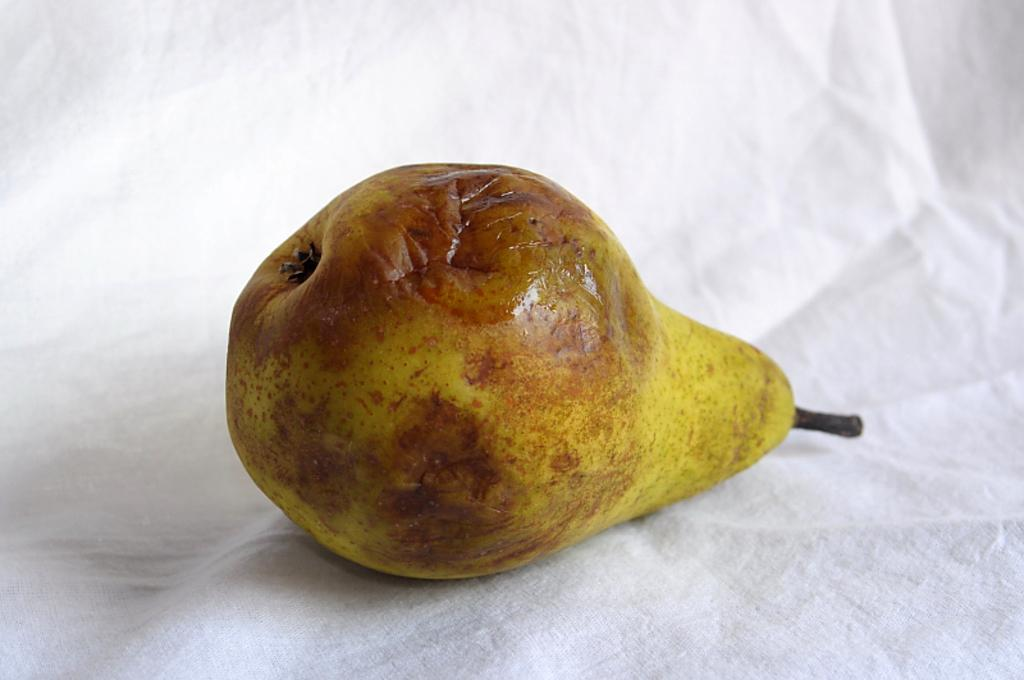What type of fruit is visible in the image? There is a pear fruit in the image. How is the pear fruit presented in the image? The pear fruit is on white tissue paper. What year is depicted in the image? The image does not depict a specific year; it only shows a pear fruit on white tissue paper. 